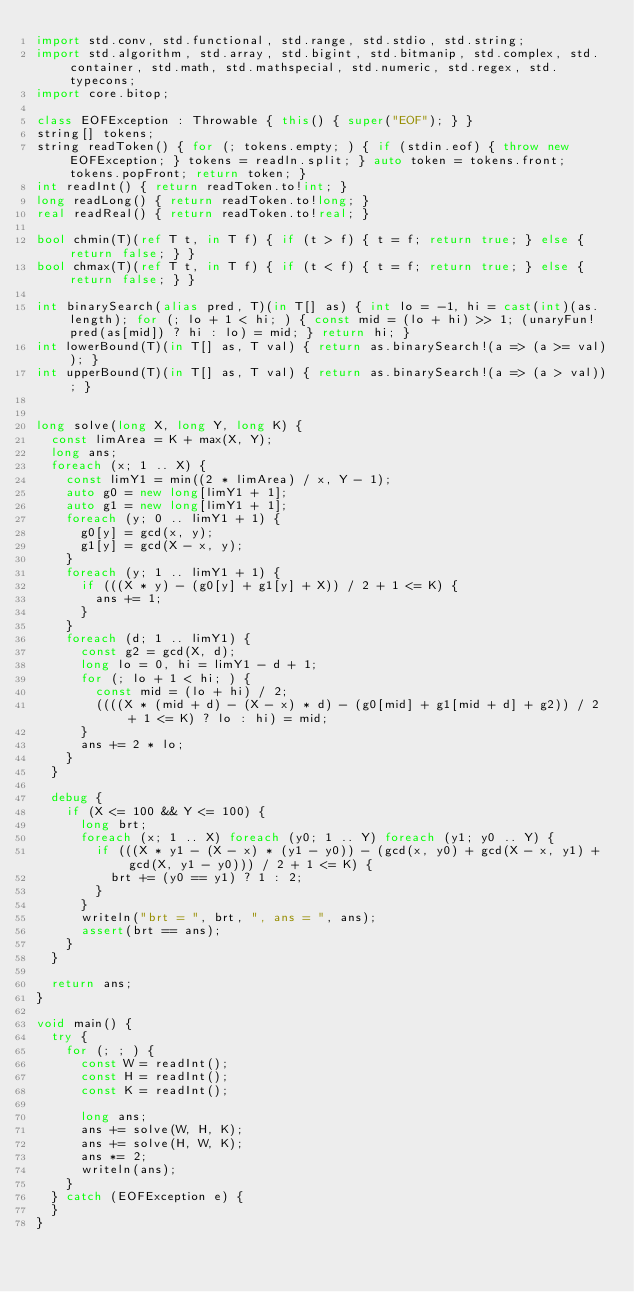<code> <loc_0><loc_0><loc_500><loc_500><_D_>import std.conv, std.functional, std.range, std.stdio, std.string;
import std.algorithm, std.array, std.bigint, std.bitmanip, std.complex, std.container, std.math, std.mathspecial, std.numeric, std.regex, std.typecons;
import core.bitop;

class EOFException : Throwable { this() { super("EOF"); } }
string[] tokens;
string readToken() { for (; tokens.empty; ) { if (stdin.eof) { throw new EOFException; } tokens = readln.split; } auto token = tokens.front; tokens.popFront; return token; }
int readInt() { return readToken.to!int; }
long readLong() { return readToken.to!long; }
real readReal() { return readToken.to!real; }

bool chmin(T)(ref T t, in T f) { if (t > f) { t = f; return true; } else { return false; } }
bool chmax(T)(ref T t, in T f) { if (t < f) { t = f; return true; } else { return false; } }

int binarySearch(alias pred, T)(in T[] as) { int lo = -1, hi = cast(int)(as.length); for (; lo + 1 < hi; ) { const mid = (lo + hi) >> 1; (unaryFun!pred(as[mid]) ? hi : lo) = mid; } return hi; }
int lowerBound(T)(in T[] as, T val) { return as.binarySearch!(a => (a >= val)); }
int upperBound(T)(in T[] as, T val) { return as.binarySearch!(a => (a > val)); }


long solve(long X, long Y, long K) {
  const limArea = K + max(X, Y);
  long ans;
  foreach (x; 1 .. X) {
    const limY1 = min((2 * limArea) / x, Y - 1);
    auto g0 = new long[limY1 + 1];
    auto g1 = new long[limY1 + 1];
    foreach (y; 0 .. limY1 + 1) {
      g0[y] = gcd(x, y);
      g1[y] = gcd(X - x, y);
    }
    foreach (y; 1 .. limY1 + 1) {
      if (((X * y) - (g0[y] + g1[y] + X)) / 2 + 1 <= K) {
        ans += 1;
      }
    }
    foreach (d; 1 .. limY1) {
      const g2 = gcd(X, d);
      long lo = 0, hi = limY1 - d + 1;
      for (; lo + 1 < hi; ) {
        const mid = (lo + hi) / 2;
        ((((X * (mid + d) - (X - x) * d) - (g0[mid] + g1[mid + d] + g2)) / 2 + 1 <= K) ? lo : hi) = mid;
      }
      ans += 2 * lo;
    }
  }
  
  debug {
    if (X <= 100 && Y <= 100) {
      long brt;
      foreach (x; 1 .. X) foreach (y0; 1 .. Y) foreach (y1; y0 .. Y) {
        if (((X * y1 - (X - x) * (y1 - y0)) - (gcd(x, y0) + gcd(X - x, y1) + gcd(X, y1 - y0))) / 2 + 1 <= K) {
          brt += (y0 == y1) ? 1 : 2;
        }
      }
      writeln("brt = ", brt, ", ans = ", ans);
      assert(brt == ans);
    }
  }
  
  return ans;
}

void main() {
  try {
    for (; ; ) {
      const W = readInt();
      const H = readInt();
      const K = readInt();
      
      long ans;
      ans += solve(W, H, K);
      ans += solve(H, W, K);
      ans *= 2;
      writeln(ans);
    }
  } catch (EOFException e) {
  }
}
</code> 